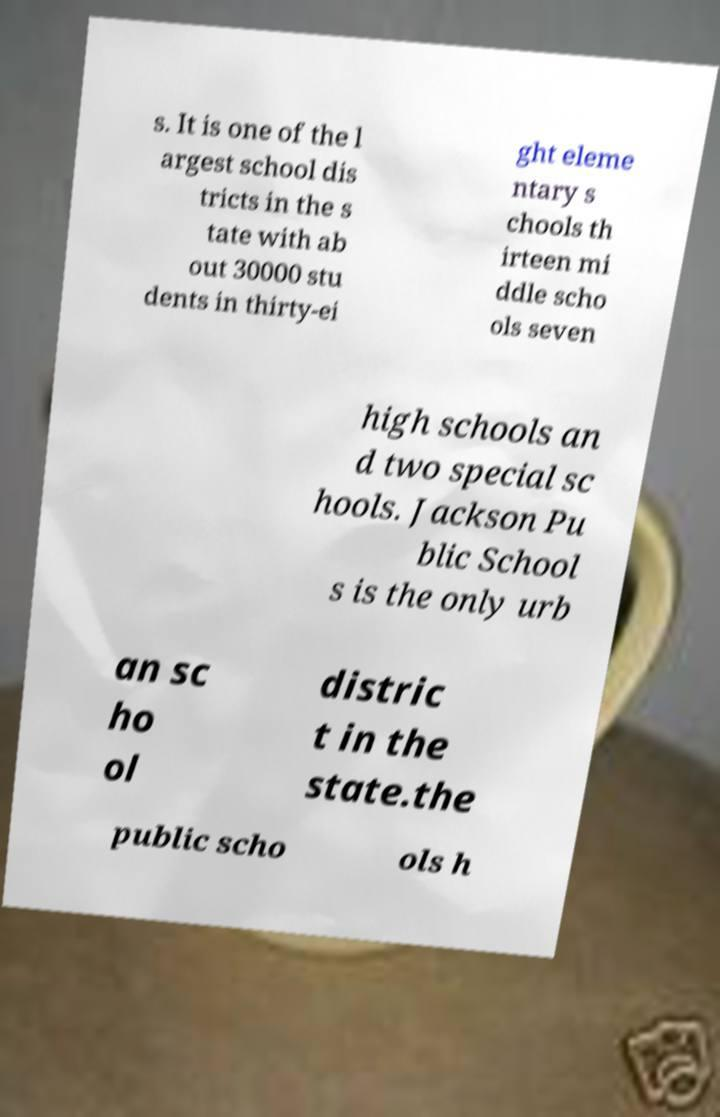Please identify and transcribe the text found in this image. s. It is one of the l argest school dis tricts in the s tate with ab out 30000 stu dents in thirty-ei ght eleme ntary s chools th irteen mi ddle scho ols seven high schools an d two special sc hools. Jackson Pu blic School s is the only urb an sc ho ol distric t in the state.the public scho ols h 